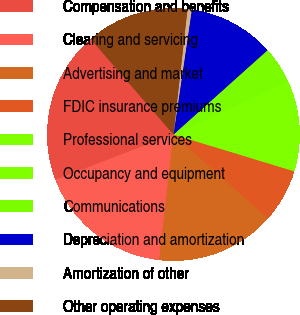<chart> <loc_0><loc_0><loc_500><loc_500><pie_chart><fcel>Compensation and benefits<fcel>Clearing and servicing<fcel>Advertising and market<fcel>FDIC insurance premiums<fcel>Professional services<fcel>Occupancy and equipment<fcel>Communications<fcel>Depreciation and amortization<fcel>Amortization of other<fcel>Other operating expenses<nl><fcel>19.46%<fcel>17.36%<fcel>15.26%<fcel>6.85%<fcel>8.95%<fcel>2.64%<fcel>4.74%<fcel>11.05%<fcel>0.54%<fcel>13.15%<nl></chart> 